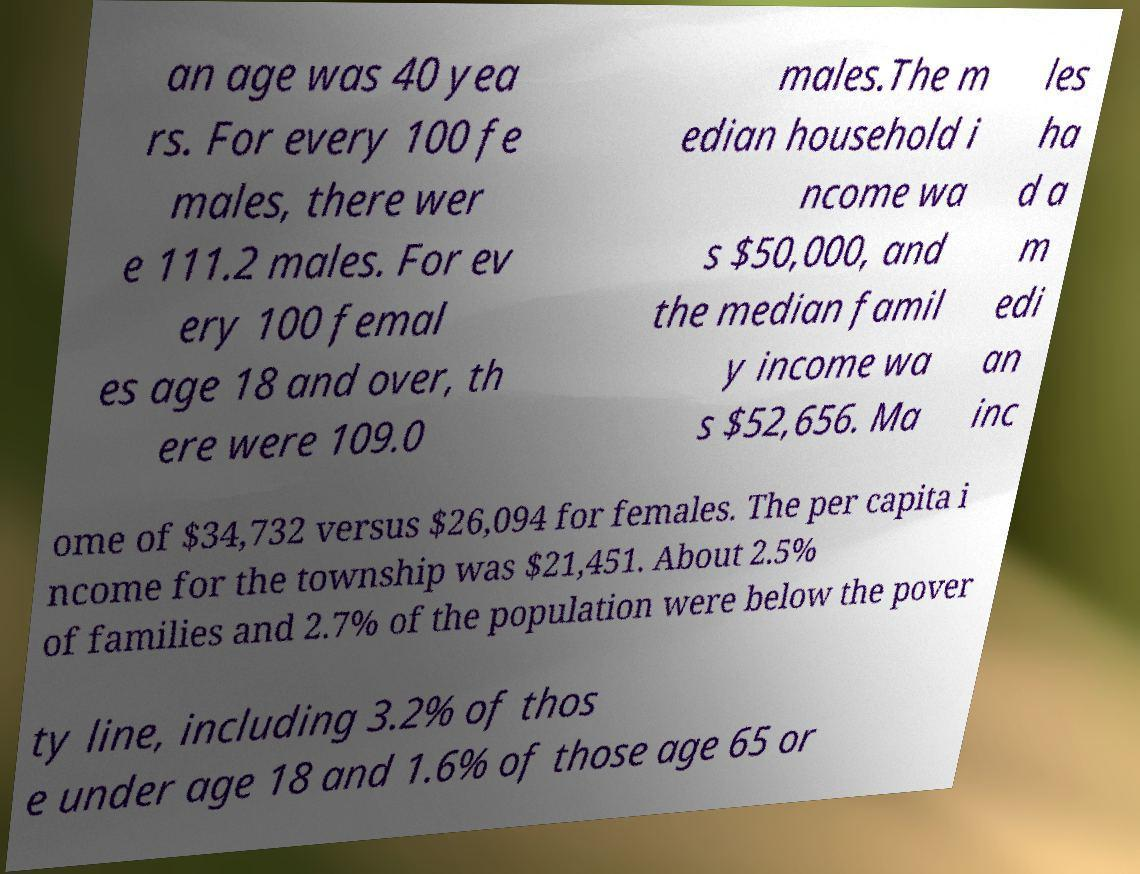Please identify and transcribe the text found in this image. an age was 40 yea rs. For every 100 fe males, there wer e 111.2 males. For ev ery 100 femal es age 18 and over, th ere were 109.0 males.The m edian household i ncome wa s $50,000, and the median famil y income wa s $52,656. Ma les ha d a m edi an inc ome of $34,732 versus $26,094 for females. The per capita i ncome for the township was $21,451. About 2.5% of families and 2.7% of the population were below the pover ty line, including 3.2% of thos e under age 18 and 1.6% of those age 65 or 